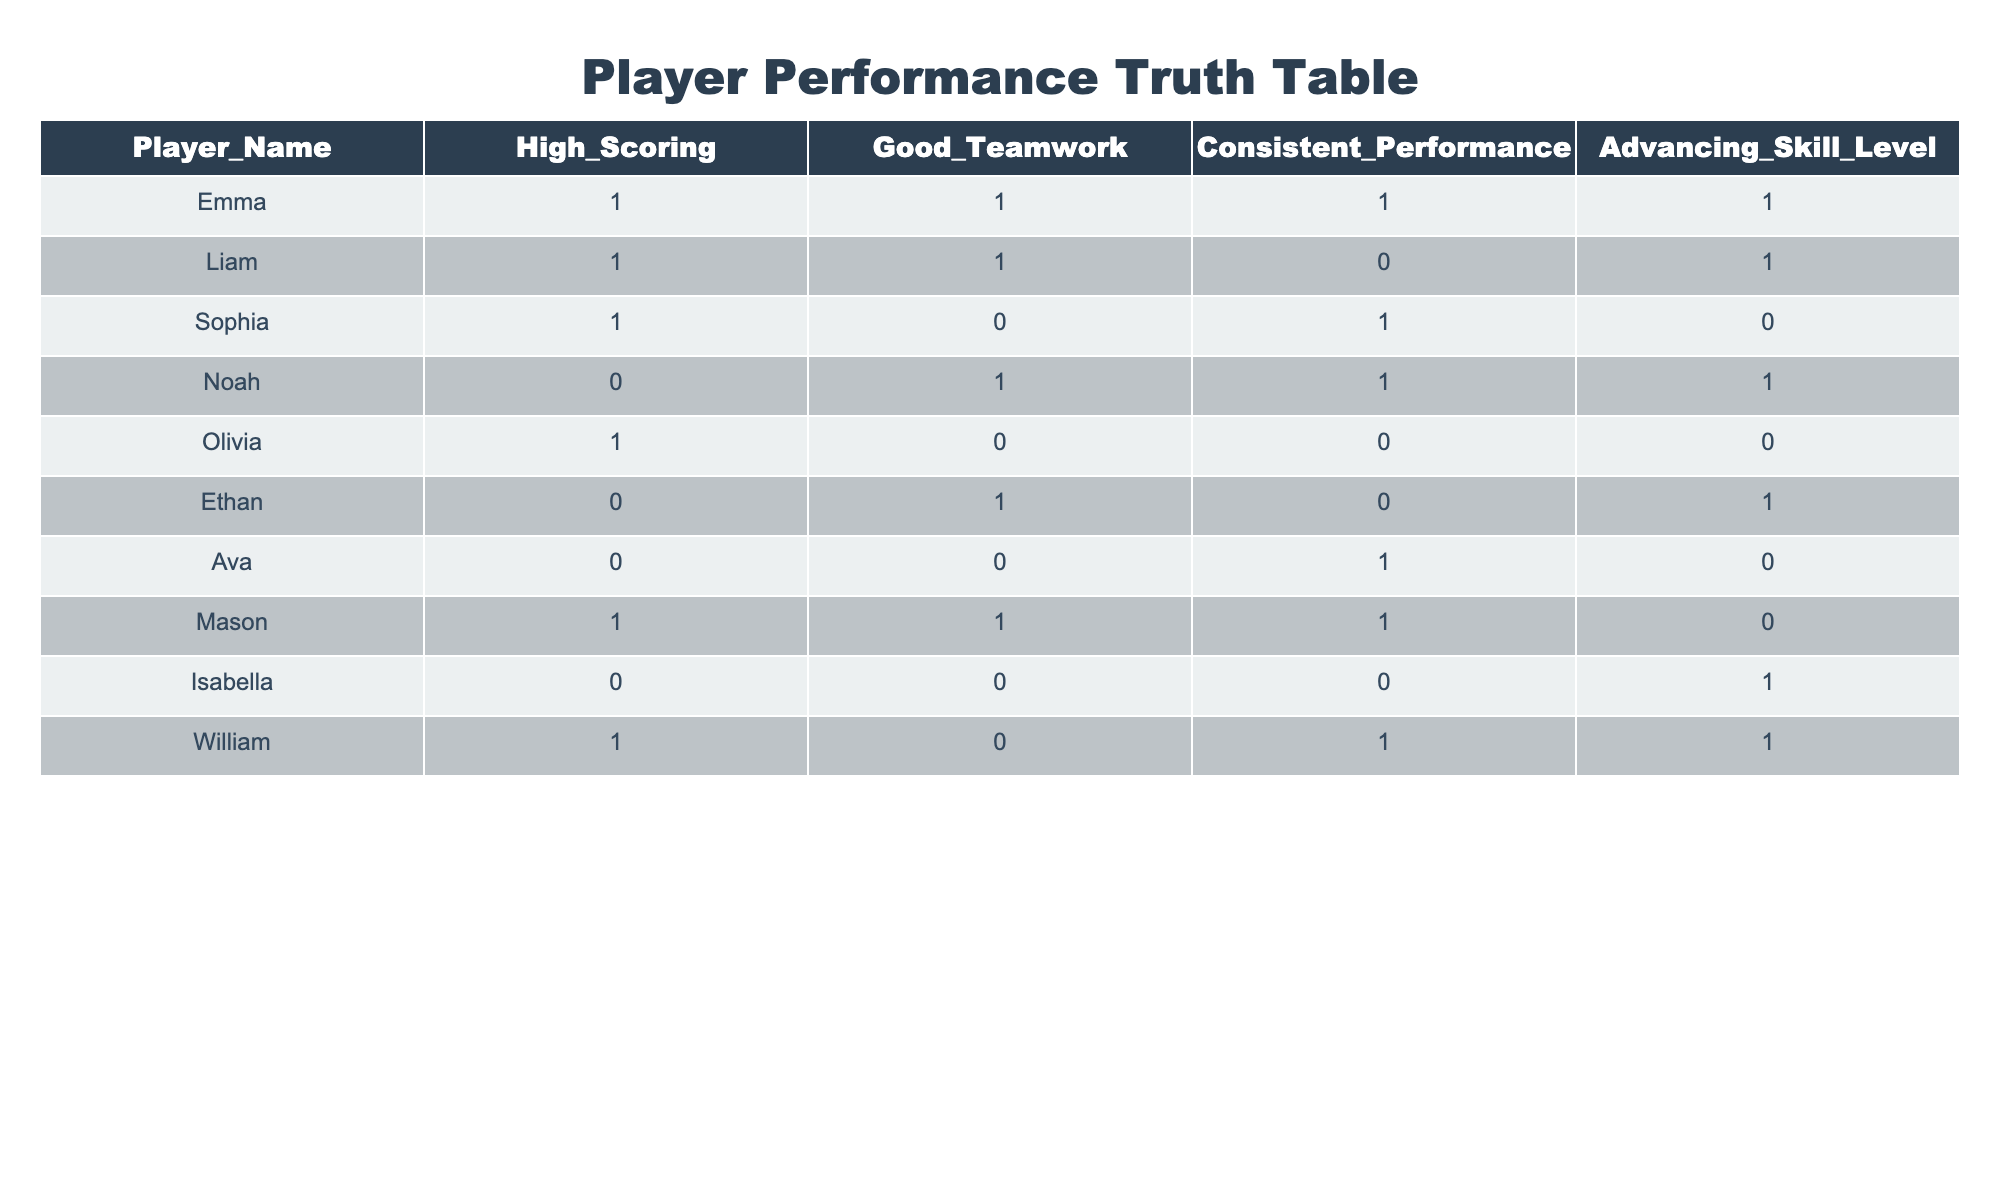What is the advancement status of Emma? Looking at the table, Emma has a value of 1 in the "Advancing_Skill_Level" column, indicating she is advancing in skill level.
Answer: 1 How many players have good teamwork and consistent performance? The table needs to be filtered for players with a value of 1 in both "Good_Teamwork" and "Consistent_Performance." Looking through the data, Emma and Noah meet these criteria. Therefore, there are 2 players.
Answer: 2 Is there a player who has high scoring but does not advance in skill level? Checking the "High_Scoring" and "Advancing_Skill_Level" columns, Mason presents a case with a high scoring of 1 and an advancing skill level of 0. Hence, the answer is yes.
Answer: Yes What is the sum of players who are advancing in skill level? We will count all players with a value of 1 in the "Advancing_Skill_Level" column. From the table, the players are Emma, Liam, Noah, Ethan, and William. The sum is 5.
Answer: 5 Which player has the highest scoring but the weakest teamwork? We look for the player with a value of 1 in "High_Scoring" and 0 in "Good_Teamwork." The player that fits this description is Liam since he is high scoring (1) but has weak teamwork (0).
Answer: Liam How many players do not have good teamwork? We need to count the number of players who have a value of 0 in the "Good_Teamwork" column. From the data, the players are Sophia, Olivia, Ethan, Ava, and Isabella, totaling 5 players.
Answer: 5 Is there a player who consistently performs but has not advanced in skill level? To answer, we check the "Consistent_Performance" column for a value of 1 and the "Advancing_Skill_Level" column for a value of 0. Ava and Mason are both consistent performers who have not advanced. Thus, there are 2 players.
Answer: 2 Are there any players that scored high while having poor teamwork and did not advance? We are looking for high scoring (1), poor teamwork (0), and not advancing (0). The relevant player here is Olivia who meets all these criteria.
Answer: Yes What percentage of players are advancing in skill level? We will find the proportion of players advancing in skill level (1) out of the total players. There are 10 players in total, and 5 are advancing (Emma, Liam, Noah, Ethan, William), giving us (5/10) * 100 = 50%.
Answer: 50% 